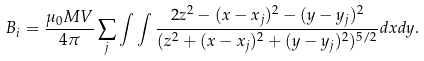Convert formula to latex. <formula><loc_0><loc_0><loc_500><loc_500>B _ { i } = \frac { \mu _ { 0 } M V } { 4 \pi } \sum _ { j } \int \int \frac { 2 z ^ { 2 } - ( x - x _ { j } ) ^ { 2 } - ( y - y _ { j } ) ^ { 2 } } { ( z ^ { 2 } + ( x - x _ { j } ) ^ { 2 } + ( y - y _ { j } ) ^ { 2 } ) ^ { 5 / 2 } } d x d y .</formula> 